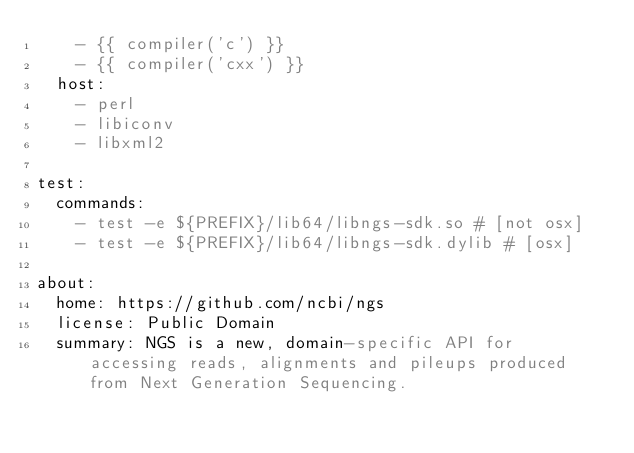<code> <loc_0><loc_0><loc_500><loc_500><_YAML_>    - {{ compiler('c') }}
    - {{ compiler('cxx') }}
  host:
    - perl
    - libiconv
    - libxml2

test:
  commands:
    - test -e ${PREFIX}/lib64/libngs-sdk.so # [not osx]
    - test -e ${PREFIX}/lib64/libngs-sdk.dylib # [osx]

about:
  home: https://github.com/ncbi/ngs
  license: Public Domain
  summary: NGS is a new, domain-specific API for accessing reads, alignments and pileups produced from Next Generation Sequencing.
</code> 